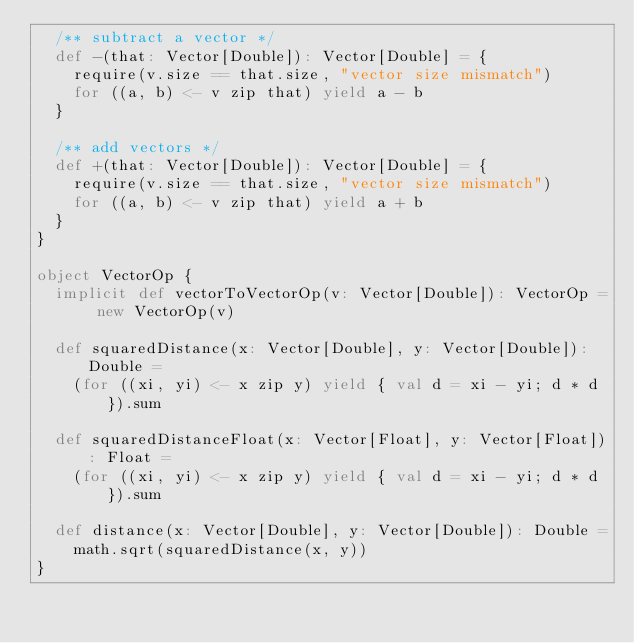<code> <loc_0><loc_0><loc_500><loc_500><_Scala_>  /** subtract a vector */
  def -(that: Vector[Double]): Vector[Double] = {
    require(v.size == that.size, "vector size mismatch")
    for ((a, b) <- v zip that) yield a - b
  }

  /** add vectors */
  def +(that: Vector[Double]): Vector[Double] = {
    require(v.size == that.size, "vector size mismatch")
    for ((a, b) <- v zip that) yield a + b
  }
}

object VectorOp {
  implicit def vectorToVectorOp(v: Vector[Double]): VectorOp = new VectorOp(v)

  def squaredDistance(x: Vector[Double], y: Vector[Double]): Double =
    (for ((xi, yi) <- x zip y) yield { val d = xi - yi; d * d }).sum

  def squaredDistanceFloat(x: Vector[Float], y: Vector[Float]): Float =
    (for ((xi, yi) <- x zip y) yield { val d = xi - yi; d * d }).sum

  def distance(x: Vector[Double], y: Vector[Double]): Double =
    math.sqrt(squaredDistance(x, y))
}</code> 